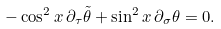Convert formula to latex. <formula><loc_0><loc_0><loc_500><loc_500>- \cos ^ { 2 } x \, \partial _ { \tau } \tilde { \theta } + \sin ^ { 2 } x \, \partial _ { \sigma } \theta = 0 .</formula> 